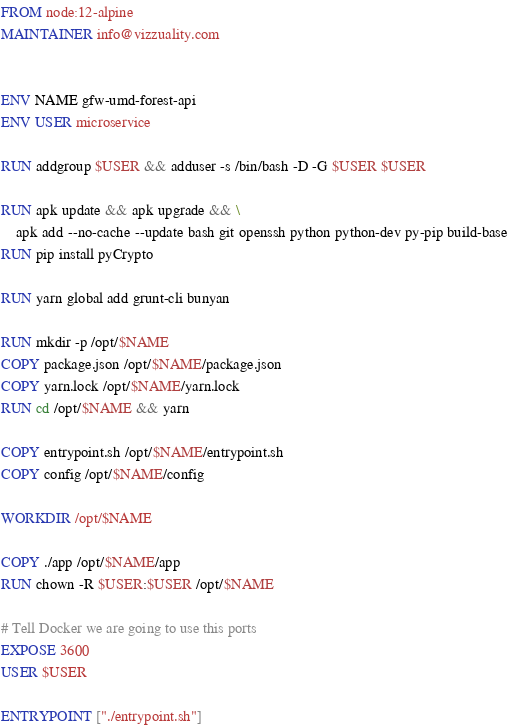<code> <loc_0><loc_0><loc_500><loc_500><_Dockerfile_>FROM node:12-alpine
MAINTAINER info@vizzuality.com


ENV NAME gfw-umd-forest-api
ENV USER microservice

RUN addgroup $USER && adduser -s /bin/bash -D -G $USER $USER

RUN apk update && apk upgrade && \
    apk add --no-cache --update bash git openssh python python-dev py-pip build-base
RUN pip install pyCrypto

RUN yarn global add grunt-cli bunyan

RUN mkdir -p /opt/$NAME
COPY package.json /opt/$NAME/package.json
COPY yarn.lock /opt/$NAME/yarn.lock
RUN cd /opt/$NAME && yarn

COPY entrypoint.sh /opt/$NAME/entrypoint.sh
COPY config /opt/$NAME/config

WORKDIR /opt/$NAME

COPY ./app /opt/$NAME/app
RUN chown -R $USER:$USER /opt/$NAME

# Tell Docker we are going to use this ports
EXPOSE 3600
USER $USER

ENTRYPOINT ["./entrypoint.sh"]
</code> 